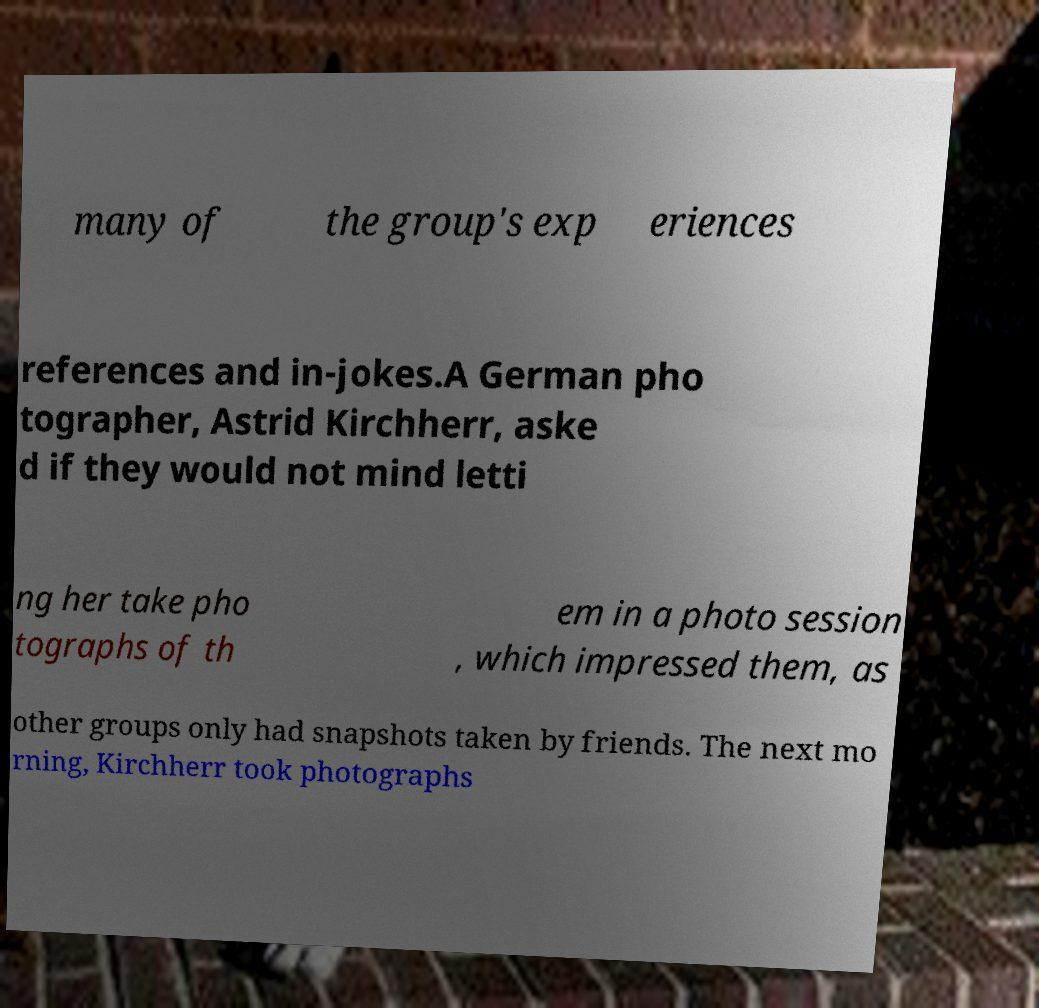There's text embedded in this image that I need extracted. Can you transcribe it verbatim? many of the group's exp eriences references and in-jokes.A German pho tographer, Astrid Kirchherr, aske d if they would not mind letti ng her take pho tographs of th em in a photo session , which impressed them, as other groups only had snapshots taken by friends. The next mo rning, Kirchherr took photographs 